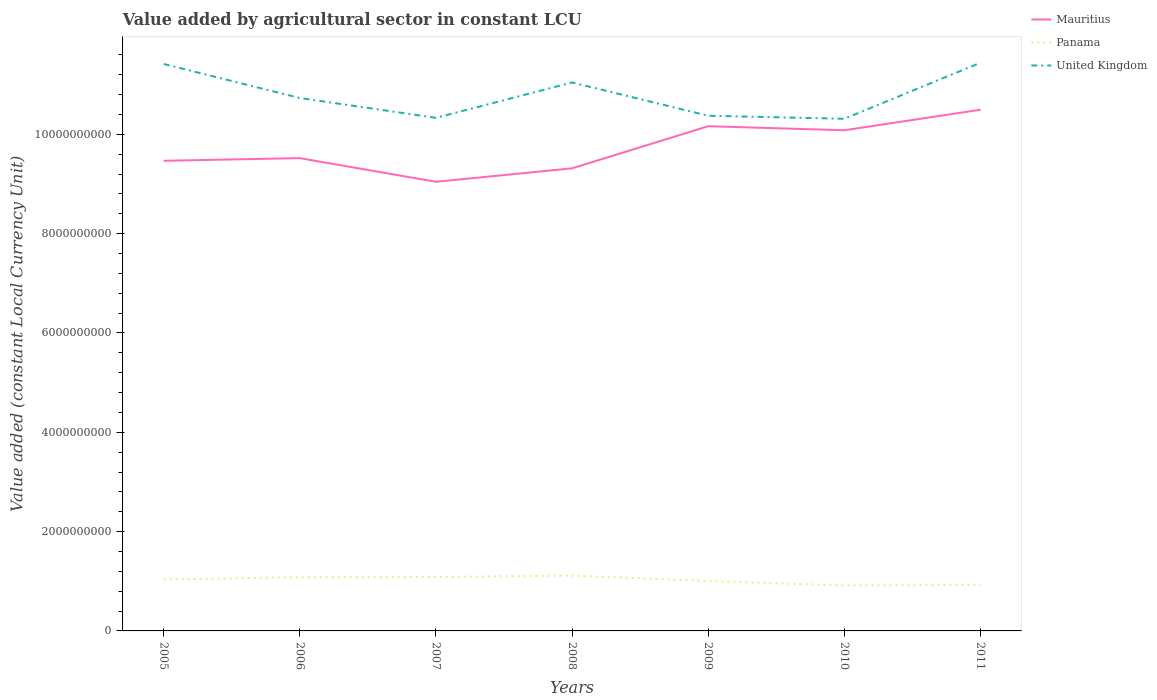How many different coloured lines are there?
Provide a short and direct response. 3. Does the line corresponding to Panama intersect with the line corresponding to Mauritius?
Give a very brief answer. No. Across all years, what is the maximum value added by agricultural sector in Mauritius?
Give a very brief answer. 9.04e+09. In which year was the value added by agricultural sector in Panama maximum?
Your response must be concise. 2010. What is the total value added by agricultural sector in United Kingdom in the graph?
Offer a terse response. -2.51e+07. What is the difference between the highest and the second highest value added by agricultural sector in Mauritius?
Keep it short and to the point. 1.45e+09. Is the value added by agricultural sector in Mauritius strictly greater than the value added by agricultural sector in United Kingdom over the years?
Keep it short and to the point. Yes. Are the values on the major ticks of Y-axis written in scientific E-notation?
Make the answer very short. No. Does the graph contain any zero values?
Your answer should be compact. No. Does the graph contain grids?
Provide a short and direct response. No. Where does the legend appear in the graph?
Offer a very short reply. Top right. How many legend labels are there?
Your response must be concise. 3. What is the title of the graph?
Your answer should be compact. Value added by agricultural sector in constant LCU. Does "Burundi" appear as one of the legend labels in the graph?
Your answer should be very brief. No. What is the label or title of the X-axis?
Your response must be concise. Years. What is the label or title of the Y-axis?
Offer a terse response. Value added (constant Local Currency Unit). What is the Value added (constant Local Currency Unit) in Mauritius in 2005?
Provide a short and direct response. 9.47e+09. What is the Value added (constant Local Currency Unit) of Panama in 2005?
Give a very brief answer. 1.04e+09. What is the Value added (constant Local Currency Unit) of United Kingdom in 2005?
Provide a succinct answer. 1.14e+1. What is the Value added (constant Local Currency Unit) in Mauritius in 2006?
Offer a terse response. 9.52e+09. What is the Value added (constant Local Currency Unit) of Panama in 2006?
Your answer should be compact. 1.08e+09. What is the Value added (constant Local Currency Unit) in United Kingdom in 2006?
Keep it short and to the point. 1.07e+1. What is the Value added (constant Local Currency Unit) in Mauritius in 2007?
Give a very brief answer. 9.04e+09. What is the Value added (constant Local Currency Unit) in Panama in 2007?
Make the answer very short. 1.09e+09. What is the Value added (constant Local Currency Unit) in United Kingdom in 2007?
Give a very brief answer. 1.03e+1. What is the Value added (constant Local Currency Unit) in Mauritius in 2008?
Your answer should be very brief. 9.32e+09. What is the Value added (constant Local Currency Unit) of Panama in 2008?
Give a very brief answer. 1.11e+09. What is the Value added (constant Local Currency Unit) of United Kingdom in 2008?
Provide a succinct answer. 1.10e+1. What is the Value added (constant Local Currency Unit) of Mauritius in 2009?
Give a very brief answer. 1.02e+1. What is the Value added (constant Local Currency Unit) in Panama in 2009?
Provide a short and direct response. 1.01e+09. What is the Value added (constant Local Currency Unit) in United Kingdom in 2009?
Your answer should be very brief. 1.04e+1. What is the Value added (constant Local Currency Unit) of Mauritius in 2010?
Offer a very short reply. 1.01e+1. What is the Value added (constant Local Currency Unit) in Panama in 2010?
Give a very brief answer. 9.15e+08. What is the Value added (constant Local Currency Unit) in United Kingdom in 2010?
Your response must be concise. 1.03e+1. What is the Value added (constant Local Currency Unit) of Mauritius in 2011?
Your response must be concise. 1.05e+1. What is the Value added (constant Local Currency Unit) in Panama in 2011?
Make the answer very short. 9.27e+08. What is the Value added (constant Local Currency Unit) in United Kingdom in 2011?
Your answer should be compact. 1.14e+1. Across all years, what is the maximum Value added (constant Local Currency Unit) in Mauritius?
Your answer should be very brief. 1.05e+1. Across all years, what is the maximum Value added (constant Local Currency Unit) in Panama?
Provide a short and direct response. 1.11e+09. Across all years, what is the maximum Value added (constant Local Currency Unit) in United Kingdom?
Provide a short and direct response. 1.14e+1. Across all years, what is the minimum Value added (constant Local Currency Unit) of Mauritius?
Give a very brief answer. 9.04e+09. Across all years, what is the minimum Value added (constant Local Currency Unit) of Panama?
Keep it short and to the point. 9.15e+08. Across all years, what is the minimum Value added (constant Local Currency Unit) of United Kingdom?
Offer a terse response. 1.03e+1. What is the total Value added (constant Local Currency Unit) in Mauritius in the graph?
Your answer should be very brief. 6.81e+1. What is the total Value added (constant Local Currency Unit) of Panama in the graph?
Your response must be concise. 7.16e+09. What is the total Value added (constant Local Currency Unit) in United Kingdom in the graph?
Offer a very short reply. 7.57e+1. What is the difference between the Value added (constant Local Currency Unit) of Mauritius in 2005 and that in 2006?
Ensure brevity in your answer.  -5.31e+07. What is the difference between the Value added (constant Local Currency Unit) in Panama in 2005 and that in 2006?
Offer a very short reply. -4.38e+07. What is the difference between the Value added (constant Local Currency Unit) of United Kingdom in 2005 and that in 2006?
Your answer should be very brief. 6.86e+08. What is the difference between the Value added (constant Local Currency Unit) in Mauritius in 2005 and that in 2007?
Offer a terse response. 4.23e+08. What is the difference between the Value added (constant Local Currency Unit) in Panama in 2005 and that in 2007?
Provide a short and direct response. -4.99e+07. What is the difference between the Value added (constant Local Currency Unit) in United Kingdom in 2005 and that in 2007?
Give a very brief answer. 1.08e+09. What is the difference between the Value added (constant Local Currency Unit) in Mauritius in 2005 and that in 2008?
Give a very brief answer. 1.52e+08. What is the difference between the Value added (constant Local Currency Unit) in Panama in 2005 and that in 2008?
Provide a short and direct response. -7.77e+07. What is the difference between the Value added (constant Local Currency Unit) in United Kingdom in 2005 and that in 2008?
Your answer should be very brief. 3.73e+08. What is the difference between the Value added (constant Local Currency Unit) in Mauritius in 2005 and that in 2009?
Make the answer very short. -6.96e+08. What is the difference between the Value added (constant Local Currency Unit) of Panama in 2005 and that in 2009?
Provide a succinct answer. 3.04e+07. What is the difference between the Value added (constant Local Currency Unit) of United Kingdom in 2005 and that in 2009?
Offer a terse response. 1.04e+09. What is the difference between the Value added (constant Local Currency Unit) of Mauritius in 2005 and that in 2010?
Your answer should be very brief. -6.15e+08. What is the difference between the Value added (constant Local Currency Unit) in Panama in 2005 and that in 2010?
Offer a very short reply. 1.21e+08. What is the difference between the Value added (constant Local Currency Unit) in United Kingdom in 2005 and that in 2010?
Make the answer very short. 1.10e+09. What is the difference between the Value added (constant Local Currency Unit) in Mauritius in 2005 and that in 2011?
Provide a short and direct response. -1.03e+09. What is the difference between the Value added (constant Local Currency Unit) of Panama in 2005 and that in 2011?
Offer a terse response. 1.09e+08. What is the difference between the Value added (constant Local Currency Unit) of United Kingdom in 2005 and that in 2011?
Keep it short and to the point. -2.51e+07. What is the difference between the Value added (constant Local Currency Unit) in Mauritius in 2006 and that in 2007?
Offer a terse response. 4.76e+08. What is the difference between the Value added (constant Local Currency Unit) in Panama in 2006 and that in 2007?
Your response must be concise. -6.13e+06. What is the difference between the Value added (constant Local Currency Unit) of United Kingdom in 2006 and that in 2007?
Provide a succinct answer. 3.99e+08. What is the difference between the Value added (constant Local Currency Unit) in Mauritius in 2006 and that in 2008?
Provide a short and direct response. 2.05e+08. What is the difference between the Value added (constant Local Currency Unit) in Panama in 2006 and that in 2008?
Your answer should be very brief. -3.39e+07. What is the difference between the Value added (constant Local Currency Unit) of United Kingdom in 2006 and that in 2008?
Make the answer very short. -3.13e+08. What is the difference between the Value added (constant Local Currency Unit) of Mauritius in 2006 and that in 2009?
Your response must be concise. -6.43e+08. What is the difference between the Value added (constant Local Currency Unit) of Panama in 2006 and that in 2009?
Ensure brevity in your answer.  7.42e+07. What is the difference between the Value added (constant Local Currency Unit) of United Kingdom in 2006 and that in 2009?
Your answer should be very brief. 3.57e+08. What is the difference between the Value added (constant Local Currency Unit) in Mauritius in 2006 and that in 2010?
Offer a terse response. -5.62e+08. What is the difference between the Value added (constant Local Currency Unit) of Panama in 2006 and that in 2010?
Give a very brief answer. 1.65e+08. What is the difference between the Value added (constant Local Currency Unit) in United Kingdom in 2006 and that in 2010?
Offer a very short reply. 4.18e+08. What is the difference between the Value added (constant Local Currency Unit) of Mauritius in 2006 and that in 2011?
Your answer should be compact. -9.75e+08. What is the difference between the Value added (constant Local Currency Unit) of Panama in 2006 and that in 2011?
Your answer should be compact. 1.53e+08. What is the difference between the Value added (constant Local Currency Unit) in United Kingdom in 2006 and that in 2011?
Make the answer very short. -7.11e+08. What is the difference between the Value added (constant Local Currency Unit) of Mauritius in 2007 and that in 2008?
Your answer should be compact. -2.71e+08. What is the difference between the Value added (constant Local Currency Unit) of Panama in 2007 and that in 2008?
Keep it short and to the point. -2.78e+07. What is the difference between the Value added (constant Local Currency Unit) in United Kingdom in 2007 and that in 2008?
Give a very brief answer. -7.12e+08. What is the difference between the Value added (constant Local Currency Unit) of Mauritius in 2007 and that in 2009?
Provide a succinct answer. -1.12e+09. What is the difference between the Value added (constant Local Currency Unit) of Panama in 2007 and that in 2009?
Provide a short and direct response. 8.03e+07. What is the difference between the Value added (constant Local Currency Unit) of United Kingdom in 2007 and that in 2009?
Ensure brevity in your answer.  -4.19e+07. What is the difference between the Value added (constant Local Currency Unit) in Mauritius in 2007 and that in 2010?
Your answer should be compact. -1.04e+09. What is the difference between the Value added (constant Local Currency Unit) in Panama in 2007 and that in 2010?
Keep it short and to the point. 1.71e+08. What is the difference between the Value added (constant Local Currency Unit) in United Kingdom in 2007 and that in 2010?
Ensure brevity in your answer.  1.88e+07. What is the difference between the Value added (constant Local Currency Unit) of Mauritius in 2007 and that in 2011?
Give a very brief answer. -1.45e+09. What is the difference between the Value added (constant Local Currency Unit) in Panama in 2007 and that in 2011?
Your response must be concise. 1.59e+08. What is the difference between the Value added (constant Local Currency Unit) of United Kingdom in 2007 and that in 2011?
Your answer should be very brief. -1.11e+09. What is the difference between the Value added (constant Local Currency Unit) of Mauritius in 2008 and that in 2009?
Offer a very short reply. -8.48e+08. What is the difference between the Value added (constant Local Currency Unit) of Panama in 2008 and that in 2009?
Make the answer very short. 1.08e+08. What is the difference between the Value added (constant Local Currency Unit) in United Kingdom in 2008 and that in 2009?
Your response must be concise. 6.70e+08. What is the difference between the Value added (constant Local Currency Unit) in Mauritius in 2008 and that in 2010?
Provide a short and direct response. -7.66e+08. What is the difference between the Value added (constant Local Currency Unit) of Panama in 2008 and that in 2010?
Offer a terse response. 1.99e+08. What is the difference between the Value added (constant Local Currency Unit) in United Kingdom in 2008 and that in 2010?
Ensure brevity in your answer.  7.31e+08. What is the difference between the Value added (constant Local Currency Unit) of Mauritius in 2008 and that in 2011?
Keep it short and to the point. -1.18e+09. What is the difference between the Value added (constant Local Currency Unit) of Panama in 2008 and that in 2011?
Offer a very short reply. 1.87e+08. What is the difference between the Value added (constant Local Currency Unit) in United Kingdom in 2008 and that in 2011?
Your answer should be very brief. -3.98e+08. What is the difference between the Value added (constant Local Currency Unit) of Mauritius in 2009 and that in 2010?
Provide a short and direct response. 8.13e+07. What is the difference between the Value added (constant Local Currency Unit) of Panama in 2009 and that in 2010?
Make the answer very short. 9.08e+07. What is the difference between the Value added (constant Local Currency Unit) of United Kingdom in 2009 and that in 2010?
Make the answer very short. 6.07e+07. What is the difference between the Value added (constant Local Currency Unit) of Mauritius in 2009 and that in 2011?
Keep it short and to the point. -3.32e+08. What is the difference between the Value added (constant Local Currency Unit) in Panama in 2009 and that in 2011?
Provide a short and direct response. 7.90e+07. What is the difference between the Value added (constant Local Currency Unit) in United Kingdom in 2009 and that in 2011?
Provide a short and direct response. -1.07e+09. What is the difference between the Value added (constant Local Currency Unit) of Mauritius in 2010 and that in 2011?
Your answer should be very brief. -4.13e+08. What is the difference between the Value added (constant Local Currency Unit) of Panama in 2010 and that in 2011?
Your response must be concise. -1.18e+07. What is the difference between the Value added (constant Local Currency Unit) in United Kingdom in 2010 and that in 2011?
Make the answer very short. -1.13e+09. What is the difference between the Value added (constant Local Currency Unit) of Mauritius in 2005 and the Value added (constant Local Currency Unit) of Panama in 2006?
Offer a terse response. 8.39e+09. What is the difference between the Value added (constant Local Currency Unit) of Mauritius in 2005 and the Value added (constant Local Currency Unit) of United Kingdom in 2006?
Your answer should be very brief. -1.26e+09. What is the difference between the Value added (constant Local Currency Unit) in Panama in 2005 and the Value added (constant Local Currency Unit) in United Kingdom in 2006?
Your answer should be very brief. -9.70e+09. What is the difference between the Value added (constant Local Currency Unit) in Mauritius in 2005 and the Value added (constant Local Currency Unit) in Panama in 2007?
Your answer should be compact. 8.38e+09. What is the difference between the Value added (constant Local Currency Unit) in Mauritius in 2005 and the Value added (constant Local Currency Unit) in United Kingdom in 2007?
Keep it short and to the point. -8.65e+08. What is the difference between the Value added (constant Local Currency Unit) in Panama in 2005 and the Value added (constant Local Currency Unit) in United Kingdom in 2007?
Give a very brief answer. -9.30e+09. What is the difference between the Value added (constant Local Currency Unit) in Mauritius in 2005 and the Value added (constant Local Currency Unit) in Panama in 2008?
Your response must be concise. 8.35e+09. What is the difference between the Value added (constant Local Currency Unit) in Mauritius in 2005 and the Value added (constant Local Currency Unit) in United Kingdom in 2008?
Your answer should be compact. -1.58e+09. What is the difference between the Value added (constant Local Currency Unit) in Panama in 2005 and the Value added (constant Local Currency Unit) in United Kingdom in 2008?
Give a very brief answer. -1.00e+1. What is the difference between the Value added (constant Local Currency Unit) of Mauritius in 2005 and the Value added (constant Local Currency Unit) of Panama in 2009?
Offer a very short reply. 8.46e+09. What is the difference between the Value added (constant Local Currency Unit) of Mauritius in 2005 and the Value added (constant Local Currency Unit) of United Kingdom in 2009?
Give a very brief answer. -9.07e+08. What is the difference between the Value added (constant Local Currency Unit) of Panama in 2005 and the Value added (constant Local Currency Unit) of United Kingdom in 2009?
Provide a short and direct response. -9.34e+09. What is the difference between the Value added (constant Local Currency Unit) in Mauritius in 2005 and the Value added (constant Local Currency Unit) in Panama in 2010?
Give a very brief answer. 8.55e+09. What is the difference between the Value added (constant Local Currency Unit) in Mauritius in 2005 and the Value added (constant Local Currency Unit) in United Kingdom in 2010?
Provide a short and direct response. -8.46e+08. What is the difference between the Value added (constant Local Currency Unit) in Panama in 2005 and the Value added (constant Local Currency Unit) in United Kingdom in 2010?
Offer a terse response. -9.28e+09. What is the difference between the Value added (constant Local Currency Unit) in Mauritius in 2005 and the Value added (constant Local Currency Unit) in Panama in 2011?
Offer a very short reply. 8.54e+09. What is the difference between the Value added (constant Local Currency Unit) of Mauritius in 2005 and the Value added (constant Local Currency Unit) of United Kingdom in 2011?
Offer a terse response. -1.97e+09. What is the difference between the Value added (constant Local Currency Unit) of Panama in 2005 and the Value added (constant Local Currency Unit) of United Kingdom in 2011?
Your answer should be very brief. -1.04e+1. What is the difference between the Value added (constant Local Currency Unit) of Mauritius in 2006 and the Value added (constant Local Currency Unit) of Panama in 2007?
Keep it short and to the point. 8.43e+09. What is the difference between the Value added (constant Local Currency Unit) of Mauritius in 2006 and the Value added (constant Local Currency Unit) of United Kingdom in 2007?
Provide a succinct answer. -8.12e+08. What is the difference between the Value added (constant Local Currency Unit) in Panama in 2006 and the Value added (constant Local Currency Unit) in United Kingdom in 2007?
Your answer should be compact. -9.25e+09. What is the difference between the Value added (constant Local Currency Unit) of Mauritius in 2006 and the Value added (constant Local Currency Unit) of Panama in 2008?
Your answer should be compact. 8.41e+09. What is the difference between the Value added (constant Local Currency Unit) of Mauritius in 2006 and the Value added (constant Local Currency Unit) of United Kingdom in 2008?
Ensure brevity in your answer.  -1.52e+09. What is the difference between the Value added (constant Local Currency Unit) of Panama in 2006 and the Value added (constant Local Currency Unit) of United Kingdom in 2008?
Provide a short and direct response. -9.96e+09. What is the difference between the Value added (constant Local Currency Unit) in Mauritius in 2006 and the Value added (constant Local Currency Unit) in Panama in 2009?
Offer a terse response. 8.52e+09. What is the difference between the Value added (constant Local Currency Unit) in Mauritius in 2006 and the Value added (constant Local Currency Unit) in United Kingdom in 2009?
Offer a very short reply. -8.54e+08. What is the difference between the Value added (constant Local Currency Unit) of Panama in 2006 and the Value added (constant Local Currency Unit) of United Kingdom in 2009?
Offer a very short reply. -9.29e+09. What is the difference between the Value added (constant Local Currency Unit) in Mauritius in 2006 and the Value added (constant Local Currency Unit) in Panama in 2010?
Provide a short and direct response. 8.61e+09. What is the difference between the Value added (constant Local Currency Unit) in Mauritius in 2006 and the Value added (constant Local Currency Unit) in United Kingdom in 2010?
Ensure brevity in your answer.  -7.93e+08. What is the difference between the Value added (constant Local Currency Unit) of Panama in 2006 and the Value added (constant Local Currency Unit) of United Kingdom in 2010?
Keep it short and to the point. -9.23e+09. What is the difference between the Value added (constant Local Currency Unit) of Mauritius in 2006 and the Value added (constant Local Currency Unit) of Panama in 2011?
Give a very brief answer. 8.59e+09. What is the difference between the Value added (constant Local Currency Unit) in Mauritius in 2006 and the Value added (constant Local Currency Unit) in United Kingdom in 2011?
Make the answer very short. -1.92e+09. What is the difference between the Value added (constant Local Currency Unit) of Panama in 2006 and the Value added (constant Local Currency Unit) of United Kingdom in 2011?
Offer a terse response. -1.04e+1. What is the difference between the Value added (constant Local Currency Unit) of Mauritius in 2007 and the Value added (constant Local Currency Unit) of Panama in 2008?
Your answer should be compact. 7.93e+09. What is the difference between the Value added (constant Local Currency Unit) of Mauritius in 2007 and the Value added (constant Local Currency Unit) of United Kingdom in 2008?
Your answer should be very brief. -2.00e+09. What is the difference between the Value added (constant Local Currency Unit) of Panama in 2007 and the Value added (constant Local Currency Unit) of United Kingdom in 2008?
Offer a very short reply. -9.96e+09. What is the difference between the Value added (constant Local Currency Unit) of Mauritius in 2007 and the Value added (constant Local Currency Unit) of Panama in 2009?
Provide a short and direct response. 8.04e+09. What is the difference between the Value added (constant Local Currency Unit) in Mauritius in 2007 and the Value added (constant Local Currency Unit) in United Kingdom in 2009?
Give a very brief answer. -1.33e+09. What is the difference between the Value added (constant Local Currency Unit) of Panama in 2007 and the Value added (constant Local Currency Unit) of United Kingdom in 2009?
Make the answer very short. -9.29e+09. What is the difference between the Value added (constant Local Currency Unit) of Mauritius in 2007 and the Value added (constant Local Currency Unit) of Panama in 2010?
Provide a short and direct response. 8.13e+09. What is the difference between the Value added (constant Local Currency Unit) in Mauritius in 2007 and the Value added (constant Local Currency Unit) in United Kingdom in 2010?
Keep it short and to the point. -1.27e+09. What is the difference between the Value added (constant Local Currency Unit) in Panama in 2007 and the Value added (constant Local Currency Unit) in United Kingdom in 2010?
Give a very brief answer. -9.23e+09. What is the difference between the Value added (constant Local Currency Unit) in Mauritius in 2007 and the Value added (constant Local Currency Unit) in Panama in 2011?
Your answer should be compact. 8.12e+09. What is the difference between the Value added (constant Local Currency Unit) in Mauritius in 2007 and the Value added (constant Local Currency Unit) in United Kingdom in 2011?
Offer a terse response. -2.40e+09. What is the difference between the Value added (constant Local Currency Unit) in Panama in 2007 and the Value added (constant Local Currency Unit) in United Kingdom in 2011?
Provide a succinct answer. -1.04e+1. What is the difference between the Value added (constant Local Currency Unit) in Mauritius in 2008 and the Value added (constant Local Currency Unit) in Panama in 2009?
Offer a very short reply. 8.31e+09. What is the difference between the Value added (constant Local Currency Unit) in Mauritius in 2008 and the Value added (constant Local Currency Unit) in United Kingdom in 2009?
Offer a terse response. -1.06e+09. What is the difference between the Value added (constant Local Currency Unit) of Panama in 2008 and the Value added (constant Local Currency Unit) of United Kingdom in 2009?
Ensure brevity in your answer.  -9.26e+09. What is the difference between the Value added (constant Local Currency Unit) of Mauritius in 2008 and the Value added (constant Local Currency Unit) of Panama in 2010?
Keep it short and to the point. 8.40e+09. What is the difference between the Value added (constant Local Currency Unit) of Mauritius in 2008 and the Value added (constant Local Currency Unit) of United Kingdom in 2010?
Ensure brevity in your answer.  -9.98e+08. What is the difference between the Value added (constant Local Currency Unit) in Panama in 2008 and the Value added (constant Local Currency Unit) in United Kingdom in 2010?
Your response must be concise. -9.20e+09. What is the difference between the Value added (constant Local Currency Unit) of Mauritius in 2008 and the Value added (constant Local Currency Unit) of Panama in 2011?
Offer a very short reply. 8.39e+09. What is the difference between the Value added (constant Local Currency Unit) of Mauritius in 2008 and the Value added (constant Local Currency Unit) of United Kingdom in 2011?
Offer a terse response. -2.13e+09. What is the difference between the Value added (constant Local Currency Unit) of Panama in 2008 and the Value added (constant Local Currency Unit) of United Kingdom in 2011?
Keep it short and to the point. -1.03e+1. What is the difference between the Value added (constant Local Currency Unit) of Mauritius in 2009 and the Value added (constant Local Currency Unit) of Panama in 2010?
Provide a succinct answer. 9.25e+09. What is the difference between the Value added (constant Local Currency Unit) in Mauritius in 2009 and the Value added (constant Local Currency Unit) in United Kingdom in 2010?
Your answer should be very brief. -1.50e+08. What is the difference between the Value added (constant Local Currency Unit) of Panama in 2009 and the Value added (constant Local Currency Unit) of United Kingdom in 2010?
Ensure brevity in your answer.  -9.31e+09. What is the difference between the Value added (constant Local Currency Unit) in Mauritius in 2009 and the Value added (constant Local Currency Unit) in Panama in 2011?
Your answer should be very brief. 9.24e+09. What is the difference between the Value added (constant Local Currency Unit) of Mauritius in 2009 and the Value added (constant Local Currency Unit) of United Kingdom in 2011?
Give a very brief answer. -1.28e+09. What is the difference between the Value added (constant Local Currency Unit) of Panama in 2009 and the Value added (constant Local Currency Unit) of United Kingdom in 2011?
Offer a very short reply. -1.04e+1. What is the difference between the Value added (constant Local Currency Unit) in Mauritius in 2010 and the Value added (constant Local Currency Unit) in Panama in 2011?
Provide a short and direct response. 9.16e+09. What is the difference between the Value added (constant Local Currency Unit) of Mauritius in 2010 and the Value added (constant Local Currency Unit) of United Kingdom in 2011?
Offer a terse response. -1.36e+09. What is the difference between the Value added (constant Local Currency Unit) in Panama in 2010 and the Value added (constant Local Currency Unit) in United Kingdom in 2011?
Your answer should be compact. -1.05e+1. What is the average Value added (constant Local Currency Unit) in Mauritius per year?
Ensure brevity in your answer.  9.73e+09. What is the average Value added (constant Local Currency Unit) of Panama per year?
Give a very brief answer. 1.02e+09. What is the average Value added (constant Local Currency Unit) of United Kingdom per year?
Offer a terse response. 1.08e+1. In the year 2005, what is the difference between the Value added (constant Local Currency Unit) of Mauritius and Value added (constant Local Currency Unit) of Panama?
Provide a short and direct response. 8.43e+09. In the year 2005, what is the difference between the Value added (constant Local Currency Unit) in Mauritius and Value added (constant Local Currency Unit) in United Kingdom?
Your response must be concise. -1.95e+09. In the year 2005, what is the difference between the Value added (constant Local Currency Unit) of Panama and Value added (constant Local Currency Unit) of United Kingdom?
Your response must be concise. -1.04e+1. In the year 2006, what is the difference between the Value added (constant Local Currency Unit) in Mauritius and Value added (constant Local Currency Unit) in Panama?
Provide a succinct answer. 8.44e+09. In the year 2006, what is the difference between the Value added (constant Local Currency Unit) of Mauritius and Value added (constant Local Currency Unit) of United Kingdom?
Your response must be concise. -1.21e+09. In the year 2006, what is the difference between the Value added (constant Local Currency Unit) in Panama and Value added (constant Local Currency Unit) in United Kingdom?
Your answer should be very brief. -9.65e+09. In the year 2007, what is the difference between the Value added (constant Local Currency Unit) in Mauritius and Value added (constant Local Currency Unit) in Panama?
Make the answer very short. 7.96e+09. In the year 2007, what is the difference between the Value added (constant Local Currency Unit) in Mauritius and Value added (constant Local Currency Unit) in United Kingdom?
Ensure brevity in your answer.  -1.29e+09. In the year 2007, what is the difference between the Value added (constant Local Currency Unit) of Panama and Value added (constant Local Currency Unit) of United Kingdom?
Keep it short and to the point. -9.25e+09. In the year 2008, what is the difference between the Value added (constant Local Currency Unit) in Mauritius and Value added (constant Local Currency Unit) in Panama?
Your answer should be very brief. 8.20e+09. In the year 2008, what is the difference between the Value added (constant Local Currency Unit) in Mauritius and Value added (constant Local Currency Unit) in United Kingdom?
Ensure brevity in your answer.  -1.73e+09. In the year 2008, what is the difference between the Value added (constant Local Currency Unit) in Panama and Value added (constant Local Currency Unit) in United Kingdom?
Offer a terse response. -9.93e+09. In the year 2009, what is the difference between the Value added (constant Local Currency Unit) of Mauritius and Value added (constant Local Currency Unit) of Panama?
Your answer should be very brief. 9.16e+09. In the year 2009, what is the difference between the Value added (constant Local Currency Unit) of Mauritius and Value added (constant Local Currency Unit) of United Kingdom?
Your answer should be compact. -2.11e+08. In the year 2009, what is the difference between the Value added (constant Local Currency Unit) of Panama and Value added (constant Local Currency Unit) of United Kingdom?
Your answer should be compact. -9.37e+09. In the year 2010, what is the difference between the Value added (constant Local Currency Unit) of Mauritius and Value added (constant Local Currency Unit) of Panama?
Offer a terse response. 9.17e+09. In the year 2010, what is the difference between the Value added (constant Local Currency Unit) of Mauritius and Value added (constant Local Currency Unit) of United Kingdom?
Provide a short and direct response. -2.31e+08. In the year 2010, what is the difference between the Value added (constant Local Currency Unit) in Panama and Value added (constant Local Currency Unit) in United Kingdom?
Your response must be concise. -9.40e+09. In the year 2011, what is the difference between the Value added (constant Local Currency Unit) of Mauritius and Value added (constant Local Currency Unit) of Panama?
Give a very brief answer. 9.57e+09. In the year 2011, what is the difference between the Value added (constant Local Currency Unit) of Mauritius and Value added (constant Local Currency Unit) of United Kingdom?
Provide a succinct answer. -9.47e+08. In the year 2011, what is the difference between the Value added (constant Local Currency Unit) in Panama and Value added (constant Local Currency Unit) in United Kingdom?
Offer a terse response. -1.05e+1. What is the ratio of the Value added (constant Local Currency Unit) of Mauritius in 2005 to that in 2006?
Keep it short and to the point. 0.99. What is the ratio of the Value added (constant Local Currency Unit) of Panama in 2005 to that in 2006?
Your response must be concise. 0.96. What is the ratio of the Value added (constant Local Currency Unit) of United Kingdom in 2005 to that in 2006?
Provide a short and direct response. 1.06. What is the ratio of the Value added (constant Local Currency Unit) in Mauritius in 2005 to that in 2007?
Your answer should be compact. 1.05. What is the ratio of the Value added (constant Local Currency Unit) of Panama in 2005 to that in 2007?
Provide a succinct answer. 0.95. What is the ratio of the Value added (constant Local Currency Unit) of United Kingdom in 2005 to that in 2007?
Your answer should be compact. 1.1. What is the ratio of the Value added (constant Local Currency Unit) in Mauritius in 2005 to that in 2008?
Your response must be concise. 1.02. What is the ratio of the Value added (constant Local Currency Unit) of Panama in 2005 to that in 2008?
Ensure brevity in your answer.  0.93. What is the ratio of the Value added (constant Local Currency Unit) in United Kingdom in 2005 to that in 2008?
Offer a terse response. 1.03. What is the ratio of the Value added (constant Local Currency Unit) in Mauritius in 2005 to that in 2009?
Your response must be concise. 0.93. What is the ratio of the Value added (constant Local Currency Unit) in Panama in 2005 to that in 2009?
Make the answer very short. 1.03. What is the ratio of the Value added (constant Local Currency Unit) in United Kingdom in 2005 to that in 2009?
Make the answer very short. 1.1. What is the ratio of the Value added (constant Local Currency Unit) in Mauritius in 2005 to that in 2010?
Your answer should be compact. 0.94. What is the ratio of the Value added (constant Local Currency Unit) of Panama in 2005 to that in 2010?
Give a very brief answer. 1.13. What is the ratio of the Value added (constant Local Currency Unit) in United Kingdom in 2005 to that in 2010?
Give a very brief answer. 1.11. What is the ratio of the Value added (constant Local Currency Unit) in Mauritius in 2005 to that in 2011?
Provide a succinct answer. 0.9. What is the ratio of the Value added (constant Local Currency Unit) in Panama in 2005 to that in 2011?
Offer a very short reply. 1.12. What is the ratio of the Value added (constant Local Currency Unit) of Mauritius in 2006 to that in 2007?
Your answer should be very brief. 1.05. What is the ratio of the Value added (constant Local Currency Unit) in Panama in 2006 to that in 2007?
Offer a terse response. 0.99. What is the ratio of the Value added (constant Local Currency Unit) of United Kingdom in 2006 to that in 2007?
Your response must be concise. 1.04. What is the ratio of the Value added (constant Local Currency Unit) of Panama in 2006 to that in 2008?
Ensure brevity in your answer.  0.97. What is the ratio of the Value added (constant Local Currency Unit) in United Kingdom in 2006 to that in 2008?
Offer a terse response. 0.97. What is the ratio of the Value added (constant Local Currency Unit) in Mauritius in 2006 to that in 2009?
Offer a terse response. 0.94. What is the ratio of the Value added (constant Local Currency Unit) of Panama in 2006 to that in 2009?
Give a very brief answer. 1.07. What is the ratio of the Value added (constant Local Currency Unit) in United Kingdom in 2006 to that in 2009?
Your answer should be compact. 1.03. What is the ratio of the Value added (constant Local Currency Unit) of Mauritius in 2006 to that in 2010?
Offer a very short reply. 0.94. What is the ratio of the Value added (constant Local Currency Unit) of Panama in 2006 to that in 2010?
Offer a terse response. 1.18. What is the ratio of the Value added (constant Local Currency Unit) of United Kingdom in 2006 to that in 2010?
Your response must be concise. 1.04. What is the ratio of the Value added (constant Local Currency Unit) of Mauritius in 2006 to that in 2011?
Provide a succinct answer. 0.91. What is the ratio of the Value added (constant Local Currency Unit) in Panama in 2006 to that in 2011?
Keep it short and to the point. 1.17. What is the ratio of the Value added (constant Local Currency Unit) of United Kingdom in 2006 to that in 2011?
Ensure brevity in your answer.  0.94. What is the ratio of the Value added (constant Local Currency Unit) in Mauritius in 2007 to that in 2008?
Offer a terse response. 0.97. What is the ratio of the Value added (constant Local Currency Unit) in Panama in 2007 to that in 2008?
Make the answer very short. 0.97. What is the ratio of the Value added (constant Local Currency Unit) of United Kingdom in 2007 to that in 2008?
Provide a succinct answer. 0.94. What is the ratio of the Value added (constant Local Currency Unit) of Mauritius in 2007 to that in 2009?
Your answer should be very brief. 0.89. What is the ratio of the Value added (constant Local Currency Unit) of Panama in 2007 to that in 2009?
Ensure brevity in your answer.  1.08. What is the ratio of the Value added (constant Local Currency Unit) in United Kingdom in 2007 to that in 2009?
Give a very brief answer. 1. What is the ratio of the Value added (constant Local Currency Unit) of Mauritius in 2007 to that in 2010?
Provide a short and direct response. 0.9. What is the ratio of the Value added (constant Local Currency Unit) in Panama in 2007 to that in 2010?
Keep it short and to the point. 1.19. What is the ratio of the Value added (constant Local Currency Unit) in Mauritius in 2007 to that in 2011?
Your answer should be compact. 0.86. What is the ratio of the Value added (constant Local Currency Unit) of Panama in 2007 to that in 2011?
Provide a succinct answer. 1.17. What is the ratio of the Value added (constant Local Currency Unit) of United Kingdom in 2007 to that in 2011?
Your answer should be compact. 0.9. What is the ratio of the Value added (constant Local Currency Unit) in Mauritius in 2008 to that in 2009?
Give a very brief answer. 0.92. What is the ratio of the Value added (constant Local Currency Unit) of Panama in 2008 to that in 2009?
Your answer should be very brief. 1.11. What is the ratio of the Value added (constant Local Currency Unit) of United Kingdom in 2008 to that in 2009?
Your answer should be very brief. 1.06. What is the ratio of the Value added (constant Local Currency Unit) in Mauritius in 2008 to that in 2010?
Provide a succinct answer. 0.92. What is the ratio of the Value added (constant Local Currency Unit) in Panama in 2008 to that in 2010?
Your answer should be very brief. 1.22. What is the ratio of the Value added (constant Local Currency Unit) in United Kingdom in 2008 to that in 2010?
Give a very brief answer. 1.07. What is the ratio of the Value added (constant Local Currency Unit) of Mauritius in 2008 to that in 2011?
Offer a terse response. 0.89. What is the ratio of the Value added (constant Local Currency Unit) of Panama in 2008 to that in 2011?
Your response must be concise. 1.2. What is the ratio of the Value added (constant Local Currency Unit) in United Kingdom in 2008 to that in 2011?
Offer a very short reply. 0.97. What is the ratio of the Value added (constant Local Currency Unit) of Mauritius in 2009 to that in 2010?
Provide a succinct answer. 1.01. What is the ratio of the Value added (constant Local Currency Unit) in Panama in 2009 to that in 2010?
Give a very brief answer. 1.1. What is the ratio of the Value added (constant Local Currency Unit) in United Kingdom in 2009 to that in 2010?
Your answer should be compact. 1.01. What is the ratio of the Value added (constant Local Currency Unit) of Mauritius in 2009 to that in 2011?
Give a very brief answer. 0.97. What is the ratio of the Value added (constant Local Currency Unit) of Panama in 2009 to that in 2011?
Your answer should be very brief. 1.09. What is the ratio of the Value added (constant Local Currency Unit) of United Kingdom in 2009 to that in 2011?
Give a very brief answer. 0.91. What is the ratio of the Value added (constant Local Currency Unit) of Mauritius in 2010 to that in 2011?
Offer a very short reply. 0.96. What is the ratio of the Value added (constant Local Currency Unit) of Panama in 2010 to that in 2011?
Provide a succinct answer. 0.99. What is the ratio of the Value added (constant Local Currency Unit) in United Kingdom in 2010 to that in 2011?
Your response must be concise. 0.9. What is the difference between the highest and the second highest Value added (constant Local Currency Unit) in Mauritius?
Your answer should be very brief. 3.32e+08. What is the difference between the highest and the second highest Value added (constant Local Currency Unit) in Panama?
Keep it short and to the point. 2.78e+07. What is the difference between the highest and the second highest Value added (constant Local Currency Unit) in United Kingdom?
Give a very brief answer. 2.51e+07. What is the difference between the highest and the lowest Value added (constant Local Currency Unit) of Mauritius?
Your response must be concise. 1.45e+09. What is the difference between the highest and the lowest Value added (constant Local Currency Unit) of Panama?
Offer a very short reply. 1.99e+08. What is the difference between the highest and the lowest Value added (constant Local Currency Unit) of United Kingdom?
Offer a very short reply. 1.13e+09. 